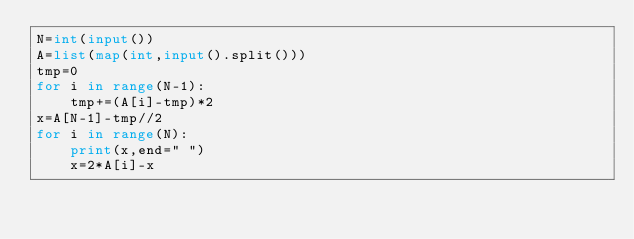Convert code to text. <code><loc_0><loc_0><loc_500><loc_500><_Python_>N=int(input())
A=list(map(int,input().split()))
tmp=0
for i in range(N-1):
    tmp+=(A[i]-tmp)*2
x=A[N-1]-tmp//2
for i in range(N):
    print(x,end=" ")
    x=2*A[i]-x</code> 